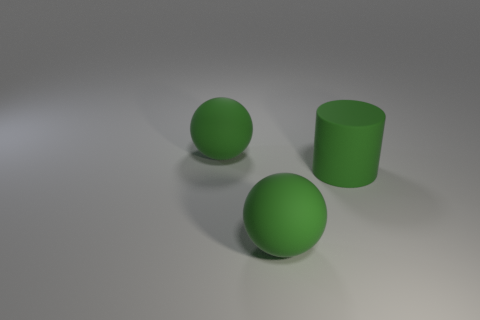Add 1 cylinders. How many objects exist? 4 Subtract 1 green balls. How many objects are left? 2 Subtract all balls. How many objects are left? 1 Subtract all brown balls. Subtract all blue blocks. How many balls are left? 2 Subtract all blue cylinders. How many brown balls are left? 0 Subtract all large blue cubes. Subtract all matte objects. How many objects are left? 0 Add 2 large green matte spheres. How many large green matte spheres are left? 4 Add 3 green balls. How many green balls exist? 5 